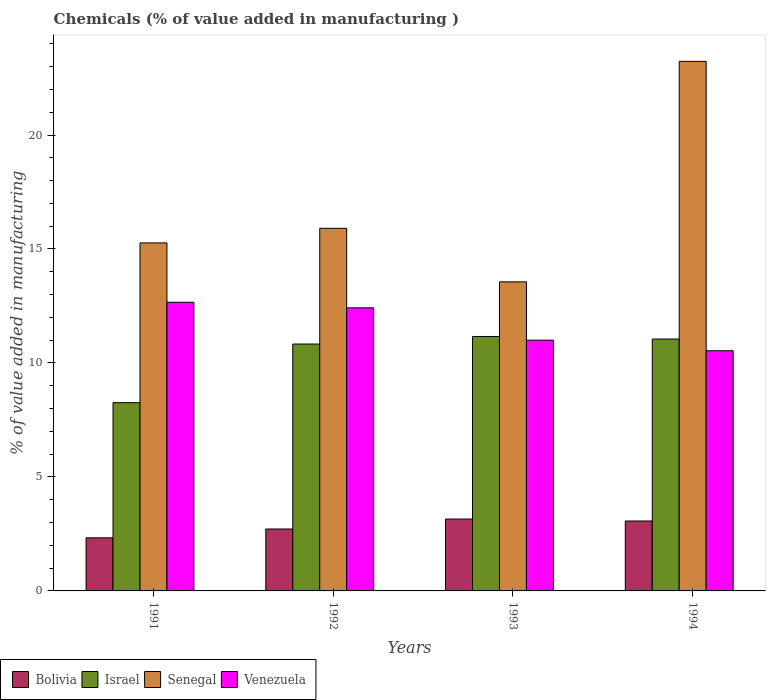How many different coloured bars are there?
Offer a terse response. 4. How many groups of bars are there?
Keep it short and to the point. 4. What is the label of the 3rd group of bars from the left?
Provide a short and direct response. 1993. In how many cases, is the number of bars for a given year not equal to the number of legend labels?
Make the answer very short. 0. What is the value added in manufacturing chemicals in Venezuela in 1991?
Make the answer very short. 12.66. Across all years, what is the maximum value added in manufacturing chemicals in Israel?
Give a very brief answer. 11.16. Across all years, what is the minimum value added in manufacturing chemicals in Israel?
Your answer should be very brief. 8.26. In which year was the value added in manufacturing chemicals in Senegal maximum?
Your answer should be very brief. 1994. In which year was the value added in manufacturing chemicals in Senegal minimum?
Provide a short and direct response. 1993. What is the total value added in manufacturing chemicals in Senegal in the graph?
Offer a very short reply. 67.96. What is the difference between the value added in manufacturing chemicals in Israel in 1991 and that in 1992?
Your response must be concise. -2.57. What is the difference between the value added in manufacturing chemicals in Senegal in 1992 and the value added in manufacturing chemicals in Venezuela in 1993?
Provide a succinct answer. 4.91. What is the average value added in manufacturing chemicals in Senegal per year?
Give a very brief answer. 16.99. In the year 1994, what is the difference between the value added in manufacturing chemicals in Bolivia and value added in manufacturing chemicals in Venezuela?
Provide a short and direct response. -7.47. In how many years, is the value added in manufacturing chemicals in Bolivia greater than 16 %?
Give a very brief answer. 0. What is the ratio of the value added in manufacturing chemicals in Bolivia in 1991 to that in 1994?
Make the answer very short. 0.76. What is the difference between the highest and the second highest value added in manufacturing chemicals in Venezuela?
Provide a succinct answer. 0.24. What is the difference between the highest and the lowest value added in manufacturing chemicals in Senegal?
Ensure brevity in your answer.  9.67. In how many years, is the value added in manufacturing chemicals in Israel greater than the average value added in manufacturing chemicals in Israel taken over all years?
Give a very brief answer. 3. Is the sum of the value added in manufacturing chemicals in Venezuela in 1991 and 1993 greater than the maximum value added in manufacturing chemicals in Israel across all years?
Offer a terse response. Yes. Is it the case that in every year, the sum of the value added in manufacturing chemicals in Israel and value added in manufacturing chemicals in Venezuela is greater than the sum of value added in manufacturing chemicals in Senegal and value added in manufacturing chemicals in Bolivia?
Give a very brief answer. No. What does the 3rd bar from the left in 1992 represents?
Offer a terse response. Senegal. What does the 4th bar from the right in 1994 represents?
Ensure brevity in your answer.  Bolivia. How many bars are there?
Offer a very short reply. 16. How many years are there in the graph?
Ensure brevity in your answer.  4. Are the values on the major ticks of Y-axis written in scientific E-notation?
Ensure brevity in your answer.  No. Does the graph contain any zero values?
Your response must be concise. No. Does the graph contain grids?
Keep it short and to the point. No. Where does the legend appear in the graph?
Provide a short and direct response. Bottom left. How many legend labels are there?
Make the answer very short. 4. What is the title of the graph?
Make the answer very short. Chemicals (% of value added in manufacturing ). What is the label or title of the Y-axis?
Provide a short and direct response. % of value added in manufacturing. What is the % of value added in manufacturing of Bolivia in 1991?
Make the answer very short. 2.33. What is the % of value added in manufacturing of Israel in 1991?
Your answer should be very brief. 8.26. What is the % of value added in manufacturing of Senegal in 1991?
Your answer should be compact. 15.27. What is the % of value added in manufacturing in Venezuela in 1991?
Make the answer very short. 12.66. What is the % of value added in manufacturing of Bolivia in 1992?
Your response must be concise. 2.72. What is the % of value added in manufacturing in Israel in 1992?
Make the answer very short. 10.83. What is the % of value added in manufacturing in Senegal in 1992?
Make the answer very short. 15.91. What is the % of value added in manufacturing in Venezuela in 1992?
Your answer should be very brief. 12.42. What is the % of value added in manufacturing in Bolivia in 1993?
Give a very brief answer. 3.15. What is the % of value added in manufacturing of Israel in 1993?
Give a very brief answer. 11.16. What is the % of value added in manufacturing of Senegal in 1993?
Ensure brevity in your answer.  13.56. What is the % of value added in manufacturing in Venezuela in 1993?
Give a very brief answer. 11. What is the % of value added in manufacturing of Bolivia in 1994?
Your answer should be compact. 3.07. What is the % of value added in manufacturing in Israel in 1994?
Your answer should be very brief. 11.05. What is the % of value added in manufacturing of Senegal in 1994?
Your answer should be very brief. 23.23. What is the % of value added in manufacturing in Venezuela in 1994?
Your answer should be compact. 10.54. Across all years, what is the maximum % of value added in manufacturing of Bolivia?
Offer a very short reply. 3.15. Across all years, what is the maximum % of value added in manufacturing of Israel?
Give a very brief answer. 11.16. Across all years, what is the maximum % of value added in manufacturing in Senegal?
Keep it short and to the point. 23.23. Across all years, what is the maximum % of value added in manufacturing of Venezuela?
Ensure brevity in your answer.  12.66. Across all years, what is the minimum % of value added in manufacturing in Bolivia?
Provide a short and direct response. 2.33. Across all years, what is the minimum % of value added in manufacturing of Israel?
Your answer should be very brief. 8.26. Across all years, what is the minimum % of value added in manufacturing in Senegal?
Ensure brevity in your answer.  13.56. Across all years, what is the minimum % of value added in manufacturing in Venezuela?
Provide a short and direct response. 10.54. What is the total % of value added in manufacturing of Bolivia in the graph?
Provide a short and direct response. 11.27. What is the total % of value added in manufacturing in Israel in the graph?
Give a very brief answer. 41.3. What is the total % of value added in manufacturing in Senegal in the graph?
Keep it short and to the point. 67.96. What is the total % of value added in manufacturing of Venezuela in the graph?
Make the answer very short. 46.62. What is the difference between the % of value added in manufacturing in Bolivia in 1991 and that in 1992?
Offer a very short reply. -0.39. What is the difference between the % of value added in manufacturing in Israel in 1991 and that in 1992?
Your answer should be very brief. -2.57. What is the difference between the % of value added in manufacturing of Senegal in 1991 and that in 1992?
Offer a very short reply. -0.64. What is the difference between the % of value added in manufacturing of Venezuela in 1991 and that in 1992?
Offer a very short reply. 0.24. What is the difference between the % of value added in manufacturing in Bolivia in 1991 and that in 1993?
Make the answer very short. -0.82. What is the difference between the % of value added in manufacturing in Israel in 1991 and that in 1993?
Offer a very short reply. -2.9. What is the difference between the % of value added in manufacturing of Senegal in 1991 and that in 1993?
Your answer should be very brief. 1.71. What is the difference between the % of value added in manufacturing in Venezuela in 1991 and that in 1993?
Your answer should be compact. 1.66. What is the difference between the % of value added in manufacturing in Bolivia in 1991 and that in 1994?
Your answer should be compact. -0.74. What is the difference between the % of value added in manufacturing in Israel in 1991 and that in 1994?
Your response must be concise. -2.79. What is the difference between the % of value added in manufacturing in Senegal in 1991 and that in 1994?
Make the answer very short. -7.97. What is the difference between the % of value added in manufacturing in Venezuela in 1991 and that in 1994?
Give a very brief answer. 2.13. What is the difference between the % of value added in manufacturing in Bolivia in 1992 and that in 1993?
Give a very brief answer. -0.44. What is the difference between the % of value added in manufacturing of Israel in 1992 and that in 1993?
Keep it short and to the point. -0.33. What is the difference between the % of value added in manufacturing in Senegal in 1992 and that in 1993?
Ensure brevity in your answer.  2.35. What is the difference between the % of value added in manufacturing of Venezuela in 1992 and that in 1993?
Offer a terse response. 1.42. What is the difference between the % of value added in manufacturing of Bolivia in 1992 and that in 1994?
Give a very brief answer. -0.35. What is the difference between the % of value added in manufacturing in Israel in 1992 and that in 1994?
Your answer should be compact. -0.22. What is the difference between the % of value added in manufacturing in Senegal in 1992 and that in 1994?
Give a very brief answer. -7.32. What is the difference between the % of value added in manufacturing of Venezuela in 1992 and that in 1994?
Keep it short and to the point. 1.88. What is the difference between the % of value added in manufacturing of Bolivia in 1993 and that in 1994?
Provide a short and direct response. 0.09. What is the difference between the % of value added in manufacturing in Israel in 1993 and that in 1994?
Your answer should be compact. 0.11. What is the difference between the % of value added in manufacturing of Senegal in 1993 and that in 1994?
Ensure brevity in your answer.  -9.67. What is the difference between the % of value added in manufacturing in Venezuela in 1993 and that in 1994?
Provide a succinct answer. 0.47. What is the difference between the % of value added in manufacturing of Bolivia in 1991 and the % of value added in manufacturing of Israel in 1992?
Keep it short and to the point. -8.5. What is the difference between the % of value added in manufacturing in Bolivia in 1991 and the % of value added in manufacturing in Senegal in 1992?
Your response must be concise. -13.58. What is the difference between the % of value added in manufacturing in Bolivia in 1991 and the % of value added in manufacturing in Venezuela in 1992?
Your response must be concise. -10.09. What is the difference between the % of value added in manufacturing of Israel in 1991 and the % of value added in manufacturing of Senegal in 1992?
Keep it short and to the point. -7.65. What is the difference between the % of value added in manufacturing of Israel in 1991 and the % of value added in manufacturing of Venezuela in 1992?
Your answer should be very brief. -4.16. What is the difference between the % of value added in manufacturing of Senegal in 1991 and the % of value added in manufacturing of Venezuela in 1992?
Offer a terse response. 2.85. What is the difference between the % of value added in manufacturing in Bolivia in 1991 and the % of value added in manufacturing in Israel in 1993?
Your answer should be very brief. -8.83. What is the difference between the % of value added in manufacturing of Bolivia in 1991 and the % of value added in manufacturing of Senegal in 1993?
Keep it short and to the point. -11.23. What is the difference between the % of value added in manufacturing of Bolivia in 1991 and the % of value added in manufacturing of Venezuela in 1993?
Your answer should be very brief. -8.67. What is the difference between the % of value added in manufacturing of Israel in 1991 and the % of value added in manufacturing of Senegal in 1993?
Your answer should be compact. -5.3. What is the difference between the % of value added in manufacturing in Israel in 1991 and the % of value added in manufacturing in Venezuela in 1993?
Make the answer very short. -2.74. What is the difference between the % of value added in manufacturing of Senegal in 1991 and the % of value added in manufacturing of Venezuela in 1993?
Provide a succinct answer. 4.27. What is the difference between the % of value added in manufacturing in Bolivia in 1991 and the % of value added in manufacturing in Israel in 1994?
Your answer should be compact. -8.72. What is the difference between the % of value added in manufacturing in Bolivia in 1991 and the % of value added in manufacturing in Senegal in 1994?
Your answer should be compact. -20.9. What is the difference between the % of value added in manufacturing of Bolivia in 1991 and the % of value added in manufacturing of Venezuela in 1994?
Offer a terse response. -8.21. What is the difference between the % of value added in manufacturing of Israel in 1991 and the % of value added in manufacturing of Senegal in 1994?
Offer a very short reply. -14.97. What is the difference between the % of value added in manufacturing of Israel in 1991 and the % of value added in manufacturing of Venezuela in 1994?
Make the answer very short. -2.28. What is the difference between the % of value added in manufacturing in Senegal in 1991 and the % of value added in manufacturing in Venezuela in 1994?
Make the answer very short. 4.73. What is the difference between the % of value added in manufacturing in Bolivia in 1992 and the % of value added in manufacturing in Israel in 1993?
Make the answer very short. -8.45. What is the difference between the % of value added in manufacturing in Bolivia in 1992 and the % of value added in manufacturing in Senegal in 1993?
Ensure brevity in your answer.  -10.84. What is the difference between the % of value added in manufacturing in Bolivia in 1992 and the % of value added in manufacturing in Venezuela in 1993?
Ensure brevity in your answer.  -8.28. What is the difference between the % of value added in manufacturing of Israel in 1992 and the % of value added in manufacturing of Senegal in 1993?
Your answer should be very brief. -2.73. What is the difference between the % of value added in manufacturing in Israel in 1992 and the % of value added in manufacturing in Venezuela in 1993?
Ensure brevity in your answer.  -0.17. What is the difference between the % of value added in manufacturing of Senegal in 1992 and the % of value added in manufacturing of Venezuela in 1993?
Make the answer very short. 4.91. What is the difference between the % of value added in manufacturing of Bolivia in 1992 and the % of value added in manufacturing of Israel in 1994?
Your answer should be very brief. -8.33. What is the difference between the % of value added in manufacturing of Bolivia in 1992 and the % of value added in manufacturing of Senegal in 1994?
Offer a terse response. -20.52. What is the difference between the % of value added in manufacturing in Bolivia in 1992 and the % of value added in manufacturing in Venezuela in 1994?
Your answer should be compact. -7.82. What is the difference between the % of value added in manufacturing in Israel in 1992 and the % of value added in manufacturing in Senegal in 1994?
Your answer should be very brief. -12.4. What is the difference between the % of value added in manufacturing of Israel in 1992 and the % of value added in manufacturing of Venezuela in 1994?
Your response must be concise. 0.3. What is the difference between the % of value added in manufacturing in Senegal in 1992 and the % of value added in manufacturing in Venezuela in 1994?
Offer a terse response. 5.37. What is the difference between the % of value added in manufacturing of Bolivia in 1993 and the % of value added in manufacturing of Israel in 1994?
Ensure brevity in your answer.  -7.9. What is the difference between the % of value added in manufacturing in Bolivia in 1993 and the % of value added in manufacturing in Senegal in 1994?
Keep it short and to the point. -20.08. What is the difference between the % of value added in manufacturing in Bolivia in 1993 and the % of value added in manufacturing in Venezuela in 1994?
Your answer should be very brief. -7.38. What is the difference between the % of value added in manufacturing in Israel in 1993 and the % of value added in manufacturing in Senegal in 1994?
Give a very brief answer. -12.07. What is the difference between the % of value added in manufacturing of Israel in 1993 and the % of value added in manufacturing of Venezuela in 1994?
Give a very brief answer. 0.63. What is the difference between the % of value added in manufacturing of Senegal in 1993 and the % of value added in manufacturing of Venezuela in 1994?
Make the answer very short. 3.02. What is the average % of value added in manufacturing of Bolivia per year?
Your response must be concise. 2.82. What is the average % of value added in manufacturing in Israel per year?
Keep it short and to the point. 10.33. What is the average % of value added in manufacturing in Senegal per year?
Provide a succinct answer. 16.99. What is the average % of value added in manufacturing in Venezuela per year?
Your answer should be compact. 11.65. In the year 1991, what is the difference between the % of value added in manufacturing of Bolivia and % of value added in manufacturing of Israel?
Your answer should be compact. -5.93. In the year 1991, what is the difference between the % of value added in manufacturing in Bolivia and % of value added in manufacturing in Senegal?
Ensure brevity in your answer.  -12.94. In the year 1991, what is the difference between the % of value added in manufacturing in Bolivia and % of value added in manufacturing in Venezuela?
Give a very brief answer. -10.33. In the year 1991, what is the difference between the % of value added in manufacturing of Israel and % of value added in manufacturing of Senegal?
Your answer should be compact. -7.01. In the year 1991, what is the difference between the % of value added in manufacturing in Israel and % of value added in manufacturing in Venezuela?
Provide a short and direct response. -4.4. In the year 1991, what is the difference between the % of value added in manufacturing in Senegal and % of value added in manufacturing in Venezuela?
Make the answer very short. 2.6. In the year 1992, what is the difference between the % of value added in manufacturing of Bolivia and % of value added in manufacturing of Israel?
Your response must be concise. -8.11. In the year 1992, what is the difference between the % of value added in manufacturing in Bolivia and % of value added in manufacturing in Senegal?
Your answer should be compact. -13.19. In the year 1992, what is the difference between the % of value added in manufacturing in Bolivia and % of value added in manufacturing in Venezuela?
Keep it short and to the point. -9.7. In the year 1992, what is the difference between the % of value added in manufacturing of Israel and % of value added in manufacturing of Senegal?
Your answer should be very brief. -5.08. In the year 1992, what is the difference between the % of value added in manufacturing of Israel and % of value added in manufacturing of Venezuela?
Your answer should be compact. -1.59. In the year 1992, what is the difference between the % of value added in manufacturing of Senegal and % of value added in manufacturing of Venezuela?
Your answer should be very brief. 3.49. In the year 1993, what is the difference between the % of value added in manufacturing of Bolivia and % of value added in manufacturing of Israel?
Offer a very short reply. -8.01. In the year 1993, what is the difference between the % of value added in manufacturing in Bolivia and % of value added in manufacturing in Senegal?
Make the answer very short. -10.41. In the year 1993, what is the difference between the % of value added in manufacturing in Bolivia and % of value added in manufacturing in Venezuela?
Make the answer very short. -7.85. In the year 1993, what is the difference between the % of value added in manufacturing in Israel and % of value added in manufacturing in Senegal?
Ensure brevity in your answer.  -2.4. In the year 1993, what is the difference between the % of value added in manufacturing of Israel and % of value added in manufacturing of Venezuela?
Make the answer very short. 0.16. In the year 1993, what is the difference between the % of value added in manufacturing in Senegal and % of value added in manufacturing in Venezuela?
Make the answer very short. 2.56. In the year 1994, what is the difference between the % of value added in manufacturing in Bolivia and % of value added in manufacturing in Israel?
Your answer should be compact. -7.98. In the year 1994, what is the difference between the % of value added in manufacturing in Bolivia and % of value added in manufacturing in Senegal?
Offer a very short reply. -20.17. In the year 1994, what is the difference between the % of value added in manufacturing of Bolivia and % of value added in manufacturing of Venezuela?
Offer a very short reply. -7.47. In the year 1994, what is the difference between the % of value added in manufacturing in Israel and % of value added in manufacturing in Senegal?
Your answer should be very brief. -12.18. In the year 1994, what is the difference between the % of value added in manufacturing of Israel and % of value added in manufacturing of Venezuela?
Make the answer very short. 0.51. In the year 1994, what is the difference between the % of value added in manufacturing in Senegal and % of value added in manufacturing in Venezuela?
Ensure brevity in your answer.  12.7. What is the ratio of the % of value added in manufacturing of Bolivia in 1991 to that in 1992?
Offer a terse response. 0.86. What is the ratio of the % of value added in manufacturing of Israel in 1991 to that in 1992?
Make the answer very short. 0.76. What is the ratio of the % of value added in manufacturing of Senegal in 1991 to that in 1992?
Ensure brevity in your answer.  0.96. What is the ratio of the % of value added in manufacturing of Venezuela in 1991 to that in 1992?
Offer a terse response. 1.02. What is the ratio of the % of value added in manufacturing in Bolivia in 1991 to that in 1993?
Ensure brevity in your answer.  0.74. What is the ratio of the % of value added in manufacturing in Israel in 1991 to that in 1993?
Your response must be concise. 0.74. What is the ratio of the % of value added in manufacturing of Senegal in 1991 to that in 1993?
Keep it short and to the point. 1.13. What is the ratio of the % of value added in manufacturing of Venezuela in 1991 to that in 1993?
Your answer should be very brief. 1.15. What is the ratio of the % of value added in manufacturing in Bolivia in 1991 to that in 1994?
Offer a terse response. 0.76. What is the ratio of the % of value added in manufacturing of Israel in 1991 to that in 1994?
Offer a very short reply. 0.75. What is the ratio of the % of value added in manufacturing of Senegal in 1991 to that in 1994?
Provide a succinct answer. 0.66. What is the ratio of the % of value added in manufacturing of Venezuela in 1991 to that in 1994?
Offer a very short reply. 1.2. What is the ratio of the % of value added in manufacturing of Bolivia in 1992 to that in 1993?
Keep it short and to the point. 0.86. What is the ratio of the % of value added in manufacturing of Israel in 1992 to that in 1993?
Your answer should be very brief. 0.97. What is the ratio of the % of value added in manufacturing of Senegal in 1992 to that in 1993?
Provide a short and direct response. 1.17. What is the ratio of the % of value added in manufacturing of Venezuela in 1992 to that in 1993?
Give a very brief answer. 1.13. What is the ratio of the % of value added in manufacturing of Bolivia in 1992 to that in 1994?
Offer a terse response. 0.89. What is the ratio of the % of value added in manufacturing in Israel in 1992 to that in 1994?
Provide a succinct answer. 0.98. What is the ratio of the % of value added in manufacturing of Senegal in 1992 to that in 1994?
Offer a very short reply. 0.68. What is the ratio of the % of value added in manufacturing in Venezuela in 1992 to that in 1994?
Your answer should be very brief. 1.18. What is the ratio of the % of value added in manufacturing in Bolivia in 1993 to that in 1994?
Give a very brief answer. 1.03. What is the ratio of the % of value added in manufacturing of Israel in 1993 to that in 1994?
Offer a very short reply. 1.01. What is the ratio of the % of value added in manufacturing of Senegal in 1993 to that in 1994?
Offer a very short reply. 0.58. What is the ratio of the % of value added in manufacturing in Venezuela in 1993 to that in 1994?
Make the answer very short. 1.04. What is the difference between the highest and the second highest % of value added in manufacturing in Bolivia?
Make the answer very short. 0.09. What is the difference between the highest and the second highest % of value added in manufacturing of Israel?
Your answer should be very brief. 0.11. What is the difference between the highest and the second highest % of value added in manufacturing of Senegal?
Offer a very short reply. 7.32. What is the difference between the highest and the second highest % of value added in manufacturing in Venezuela?
Your answer should be very brief. 0.24. What is the difference between the highest and the lowest % of value added in manufacturing of Bolivia?
Provide a short and direct response. 0.82. What is the difference between the highest and the lowest % of value added in manufacturing in Israel?
Give a very brief answer. 2.9. What is the difference between the highest and the lowest % of value added in manufacturing in Senegal?
Keep it short and to the point. 9.67. What is the difference between the highest and the lowest % of value added in manufacturing in Venezuela?
Provide a short and direct response. 2.13. 